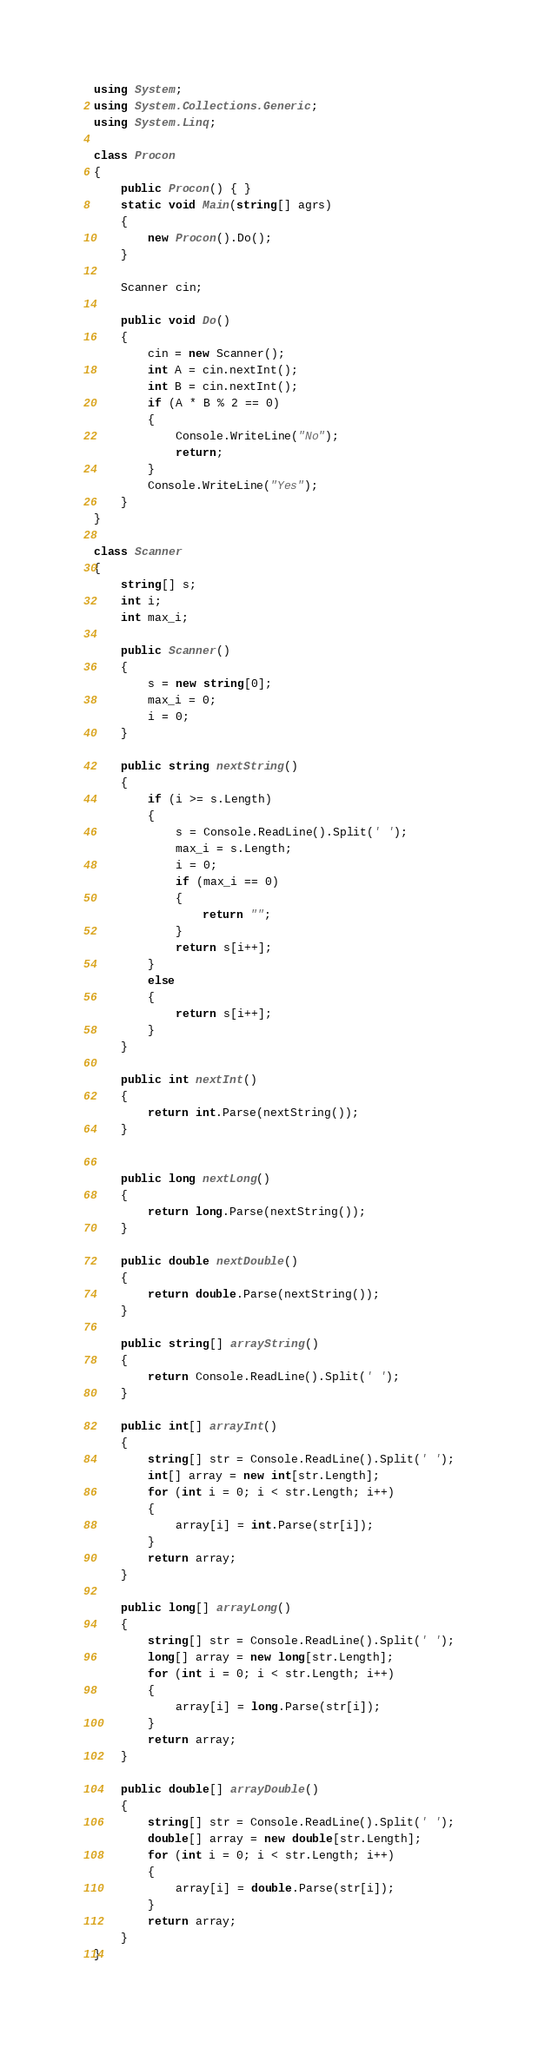<code> <loc_0><loc_0><loc_500><loc_500><_C#_>using System;
using System.Collections.Generic;
using System.Linq;

class Procon
{
    public Procon() { }
    static void Main(string[] agrs)
    {
        new Procon().Do();
    }

    Scanner cin;

    public void Do()
    {
        cin = new Scanner();
        int A = cin.nextInt();
        int B = cin.nextInt();
        if (A * B % 2 == 0)
        {
            Console.WriteLine("No");
            return;
        }
        Console.WriteLine("Yes");
    }
}

class Scanner
{
    string[] s;
    int i;
    int max_i;

    public Scanner()
    {
        s = new string[0];
        max_i = 0;
        i = 0;
    }

    public string nextString()
    {
        if (i >= s.Length)
        {
            s = Console.ReadLine().Split(' ');
            max_i = s.Length;
            i = 0;
            if (max_i == 0)
            {
                return "";
            }
            return s[i++];
        }
        else
        {
            return s[i++];
        }
    }

    public int nextInt()
    {
        return int.Parse(nextString());
    }


    public long nextLong()
    {
        return long.Parse(nextString());
    }

    public double nextDouble()
    {
        return double.Parse(nextString());
    }

    public string[] arrayString()
    {
        return Console.ReadLine().Split(' ');
    }

    public int[] arrayInt()
    {
        string[] str = Console.ReadLine().Split(' ');
        int[] array = new int[str.Length];
        for (int i = 0; i < str.Length; i++)
        {
            array[i] = int.Parse(str[i]);
        }
        return array;
    }

    public long[] arrayLong()
    {
        string[] str = Console.ReadLine().Split(' ');
        long[] array = new long[str.Length];
        for (int i = 0; i < str.Length; i++)
        {
            array[i] = long.Parse(str[i]);
        }
        return array;
    }

    public double[] arrayDouble()
    {
        string[] str = Console.ReadLine().Split(' ');
        double[] array = new double[str.Length];
        for (int i = 0; i < str.Length; i++)
        {
            array[i] = double.Parse(str[i]);
        }
        return array;
    }
}

</code> 